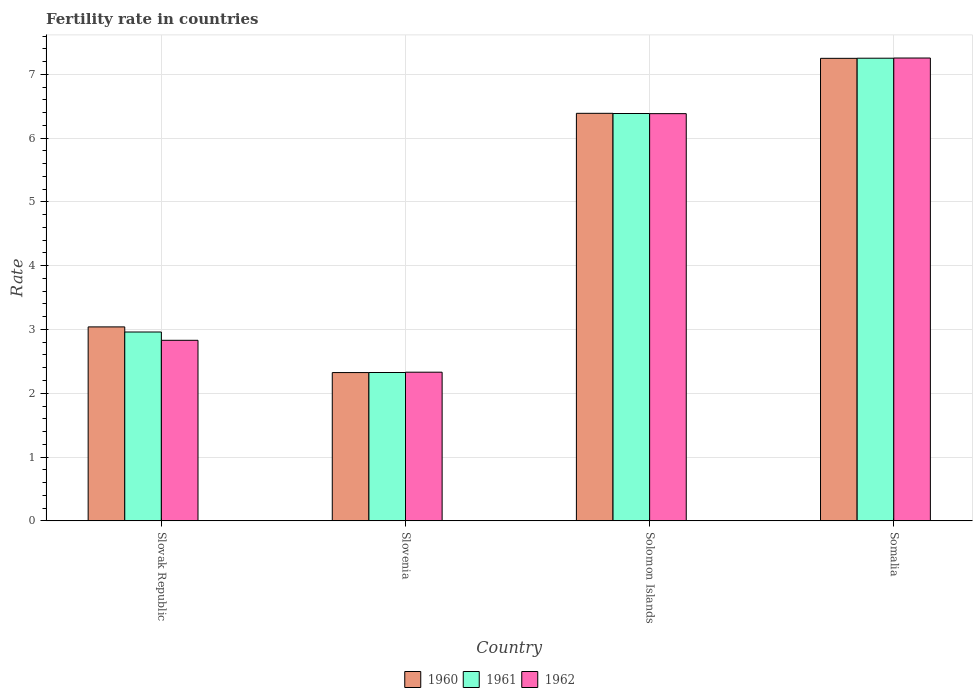How many different coloured bars are there?
Your answer should be compact. 3. How many groups of bars are there?
Offer a very short reply. 4. Are the number of bars per tick equal to the number of legend labels?
Make the answer very short. Yes. Are the number of bars on each tick of the X-axis equal?
Keep it short and to the point. Yes. How many bars are there on the 3rd tick from the right?
Provide a short and direct response. 3. What is the label of the 4th group of bars from the left?
Give a very brief answer. Somalia. In how many cases, is the number of bars for a given country not equal to the number of legend labels?
Your answer should be compact. 0. What is the fertility rate in 1962 in Somalia?
Your answer should be very brief. 7.25. Across all countries, what is the maximum fertility rate in 1961?
Your answer should be compact. 7.25. Across all countries, what is the minimum fertility rate in 1961?
Your answer should be very brief. 2.33. In which country was the fertility rate in 1960 maximum?
Offer a very short reply. Somalia. In which country was the fertility rate in 1962 minimum?
Keep it short and to the point. Slovenia. What is the total fertility rate in 1960 in the graph?
Your answer should be compact. 19. What is the difference between the fertility rate in 1960 in Slovak Republic and that in Somalia?
Make the answer very short. -4.21. What is the difference between the fertility rate in 1960 in Slovenia and the fertility rate in 1962 in Slovak Republic?
Offer a terse response. -0.51. What is the average fertility rate in 1962 per country?
Give a very brief answer. 4.7. What is the difference between the fertility rate of/in 1962 and fertility rate of/in 1960 in Slovak Republic?
Offer a very short reply. -0.21. In how many countries, is the fertility rate in 1960 greater than 5.2?
Your response must be concise. 2. What is the ratio of the fertility rate in 1960 in Slovak Republic to that in Slovenia?
Make the answer very short. 1.31. Is the fertility rate in 1962 in Slovenia less than that in Solomon Islands?
Offer a terse response. Yes. What is the difference between the highest and the second highest fertility rate in 1962?
Provide a short and direct response. -3.55. What is the difference between the highest and the lowest fertility rate in 1960?
Provide a succinct answer. 4.93. Is the sum of the fertility rate in 1962 in Slovak Republic and Slovenia greater than the maximum fertility rate in 1961 across all countries?
Provide a short and direct response. No. What does the 2nd bar from the right in Slovak Republic represents?
Keep it short and to the point. 1961. How many countries are there in the graph?
Your answer should be compact. 4. What is the difference between two consecutive major ticks on the Y-axis?
Your response must be concise. 1. Are the values on the major ticks of Y-axis written in scientific E-notation?
Provide a short and direct response. No. Does the graph contain any zero values?
Provide a short and direct response. No. Does the graph contain grids?
Offer a very short reply. Yes. How are the legend labels stacked?
Offer a terse response. Horizontal. What is the title of the graph?
Your answer should be compact. Fertility rate in countries. Does "1968" appear as one of the legend labels in the graph?
Offer a very short reply. No. What is the label or title of the Y-axis?
Offer a terse response. Rate. What is the Rate in 1960 in Slovak Republic?
Provide a succinct answer. 3.04. What is the Rate of 1961 in Slovak Republic?
Ensure brevity in your answer.  2.96. What is the Rate in 1962 in Slovak Republic?
Give a very brief answer. 2.83. What is the Rate in 1960 in Slovenia?
Ensure brevity in your answer.  2.32. What is the Rate in 1961 in Slovenia?
Provide a short and direct response. 2.33. What is the Rate in 1962 in Slovenia?
Your response must be concise. 2.33. What is the Rate of 1960 in Solomon Islands?
Provide a short and direct response. 6.39. What is the Rate in 1961 in Solomon Islands?
Keep it short and to the point. 6.38. What is the Rate of 1962 in Solomon Islands?
Your answer should be very brief. 6.38. What is the Rate of 1960 in Somalia?
Offer a very short reply. 7.25. What is the Rate in 1961 in Somalia?
Provide a short and direct response. 7.25. What is the Rate in 1962 in Somalia?
Provide a short and direct response. 7.25. Across all countries, what is the maximum Rate in 1960?
Your response must be concise. 7.25. Across all countries, what is the maximum Rate in 1961?
Make the answer very short. 7.25. Across all countries, what is the maximum Rate in 1962?
Your answer should be very brief. 7.25. Across all countries, what is the minimum Rate in 1960?
Your answer should be compact. 2.32. Across all countries, what is the minimum Rate in 1961?
Your answer should be very brief. 2.33. Across all countries, what is the minimum Rate of 1962?
Offer a terse response. 2.33. What is the total Rate of 1960 in the graph?
Ensure brevity in your answer.  19. What is the total Rate in 1961 in the graph?
Give a very brief answer. 18.92. What is the total Rate of 1962 in the graph?
Offer a terse response. 18.8. What is the difference between the Rate of 1960 in Slovak Republic and that in Slovenia?
Your response must be concise. 0.72. What is the difference between the Rate in 1961 in Slovak Republic and that in Slovenia?
Your answer should be very brief. 0.64. What is the difference between the Rate of 1962 in Slovak Republic and that in Slovenia?
Your answer should be very brief. 0.5. What is the difference between the Rate in 1960 in Slovak Republic and that in Solomon Islands?
Provide a succinct answer. -3.35. What is the difference between the Rate of 1961 in Slovak Republic and that in Solomon Islands?
Give a very brief answer. -3.42. What is the difference between the Rate of 1962 in Slovak Republic and that in Solomon Islands?
Provide a succinct answer. -3.55. What is the difference between the Rate in 1960 in Slovak Republic and that in Somalia?
Provide a succinct answer. -4.21. What is the difference between the Rate of 1961 in Slovak Republic and that in Somalia?
Provide a succinct answer. -4.29. What is the difference between the Rate in 1962 in Slovak Republic and that in Somalia?
Offer a terse response. -4.42. What is the difference between the Rate of 1960 in Slovenia and that in Solomon Islands?
Provide a short and direct response. -4.06. What is the difference between the Rate of 1961 in Slovenia and that in Solomon Islands?
Keep it short and to the point. -4.06. What is the difference between the Rate in 1962 in Slovenia and that in Solomon Islands?
Your answer should be very brief. -4.05. What is the difference between the Rate in 1960 in Slovenia and that in Somalia?
Offer a very short reply. -4.93. What is the difference between the Rate in 1961 in Slovenia and that in Somalia?
Ensure brevity in your answer.  -4.93. What is the difference between the Rate of 1962 in Slovenia and that in Somalia?
Your answer should be compact. -4.92. What is the difference between the Rate in 1960 in Solomon Islands and that in Somalia?
Your answer should be very brief. -0.86. What is the difference between the Rate of 1961 in Solomon Islands and that in Somalia?
Give a very brief answer. -0.87. What is the difference between the Rate of 1962 in Solomon Islands and that in Somalia?
Provide a succinct answer. -0.87. What is the difference between the Rate of 1960 in Slovak Republic and the Rate of 1961 in Slovenia?
Make the answer very short. 0.71. What is the difference between the Rate of 1960 in Slovak Republic and the Rate of 1962 in Slovenia?
Make the answer very short. 0.71. What is the difference between the Rate of 1961 in Slovak Republic and the Rate of 1962 in Slovenia?
Your answer should be very brief. 0.63. What is the difference between the Rate in 1960 in Slovak Republic and the Rate in 1961 in Solomon Islands?
Keep it short and to the point. -3.35. What is the difference between the Rate of 1960 in Slovak Republic and the Rate of 1962 in Solomon Islands?
Keep it short and to the point. -3.34. What is the difference between the Rate of 1961 in Slovak Republic and the Rate of 1962 in Solomon Islands?
Ensure brevity in your answer.  -3.42. What is the difference between the Rate of 1960 in Slovak Republic and the Rate of 1961 in Somalia?
Your answer should be very brief. -4.21. What is the difference between the Rate in 1960 in Slovak Republic and the Rate in 1962 in Somalia?
Ensure brevity in your answer.  -4.21. What is the difference between the Rate of 1961 in Slovak Republic and the Rate of 1962 in Somalia?
Offer a very short reply. -4.29. What is the difference between the Rate of 1960 in Slovenia and the Rate of 1961 in Solomon Islands?
Provide a succinct answer. -4.06. What is the difference between the Rate in 1960 in Slovenia and the Rate in 1962 in Solomon Islands?
Your answer should be very brief. -4.06. What is the difference between the Rate of 1961 in Slovenia and the Rate of 1962 in Solomon Islands?
Your answer should be compact. -4.06. What is the difference between the Rate of 1960 in Slovenia and the Rate of 1961 in Somalia?
Make the answer very short. -4.93. What is the difference between the Rate in 1960 in Slovenia and the Rate in 1962 in Somalia?
Offer a very short reply. -4.93. What is the difference between the Rate of 1961 in Slovenia and the Rate of 1962 in Somalia?
Provide a short and direct response. -4.93. What is the difference between the Rate of 1960 in Solomon Islands and the Rate of 1961 in Somalia?
Make the answer very short. -0.86. What is the difference between the Rate in 1960 in Solomon Islands and the Rate in 1962 in Somalia?
Keep it short and to the point. -0.87. What is the difference between the Rate in 1961 in Solomon Islands and the Rate in 1962 in Somalia?
Offer a very short reply. -0.87. What is the average Rate of 1960 per country?
Keep it short and to the point. 4.75. What is the average Rate of 1961 per country?
Keep it short and to the point. 4.73. What is the average Rate in 1962 per country?
Make the answer very short. 4.7. What is the difference between the Rate in 1960 and Rate in 1961 in Slovak Republic?
Your response must be concise. 0.08. What is the difference between the Rate of 1960 and Rate of 1962 in Slovak Republic?
Provide a short and direct response. 0.21. What is the difference between the Rate of 1961 and Rate of 1962 in Slovak Republic?
Your response must be concise. 0.13. What is the difference between the Rate of 1960 and Rate of 1961 in Slovenia?
Your response must be concise. -0. What is the difference between the Rate in 1960 and Rate in 1962 in Slovenia?
Provide a succinct answer. -0.01. What is the difference between the Rate in 1961 and Rate in 1962 in Slovenia?
Your answer should be compact. -0.01. What is the difference between the Rate in 1960 and Rate in 1961 in Solomon Islands?
Give a very brief answer. 0. What is the difference between the Rate of 1960 and Rate of 1962 in Solomon Islands?
Give a very brief answer. 0.01. What is the difference between the Rate of 1961 and Rate of 1962 in Solomon Islands?
Provide a succinct answer. 0. What is the difference between the Rate of 1960 and Rate of 1961 in Somalia?
Your response must be concise. -0. What is the difference between the Rate of 1960 and Rate of 1962 in Somalia?
Offer a very short reply. -0.01. What is the difference between the Rate of 1961 and Rate of 1962 in Somalia?
Ensure brevity in your answer.  -0. What is the ratio of the Rate of 1960 in Slovak Republic to that in Slovenia?
Make the answer very short. 1.31. What is the ratio of the Rate in 1961 in Slovak Republic to that in Slovenia?
Provide a succinct answer. 1.27. What is the ratio of the Rate in 1962 in Slovak Republic to that in Slovenia?
Provide a short and direct response. 1.21. What is the ratio of the Rate in 1960 in Slovak Republic to that in Solomon Islands?
Your answer should be very brief. 0.48. What is the ratio of the Rate in 1961 in Slovak Republic to that in Solomon Islands?
Your answer should be very brief. 0.46. What is the ratio of the Rate in 1962 in Slovak Republic to that in Solomon Islands?
Make the answer very short. 0.44. What is the ratio of the Rate in 1960 in Slovak Republic to that in Somalia?
Give a very brief answer. 0.42. What is the ratio of the Rate of 1961 in Slovak Republic to that in Somalia?
Ensure brevity in your answer.  0.41. What is the ratio of the Rate of 1962 in Slovak Republic to that in Somalia?
Make the answer very short. 0.39. What is the ratio of the Rate of 1960 in Slovenia to that in Solomon Islands?
Your response must be concise. 0.36. What is the ratio of the Rate of 1961 in Slovenia to that in Solomon Islands?
Provide a short and direct response. 0.36. What is the ratio of the Rate of 1962 in Slovenia to that in Solomon Islands?
Ensure brevity in your answer.  0.36. What is the ratio of the Rate in 1960 in Slovenia to that in Somalia?
Keep it short and to the point. 0.32. What is the ratio of the Rate in 1961 in Slovenia to that in Somalia?
Your answer should be very brief. 0.32. What is the ratio of the Rate in 1962 in Slovenia to that in Somalia?
Ensure brevity in your answer.  0.32. What is the ratio of the Rate in 1960 in Solomon Islands to that in Somalia?
Offer a terse response. 0.88. What is the ratio of the Rate of 1961 in Solomon Islands to that in Somalia?
Provide a succinct answer. 0.88. What is the ratio of the Rate of 1962 in Solomon Islands to that in Somalia?
Provide a succinct answer. 0.88. What is the difference between the highest and the second highest Rate in 1960?
Your answer should be very brief. 0.86. What is the difference between the highest and the second highest Rate of 1961?
Keep it short and to the point. 0.87. What is the difference between the highest and the second highest Rate of 1962?
Your answer should be compact. 0.87. What is the difference between the highest and the lowest Rate in 1960?
Your answer should be very brief. 4.93. What is the difference between the highest and the lowest Rate of 1961?
Your answer should be compact. 4.93. What is the difference between the highest and the lowest Rate of 1962?
Offer a very short reply. 4.92. 